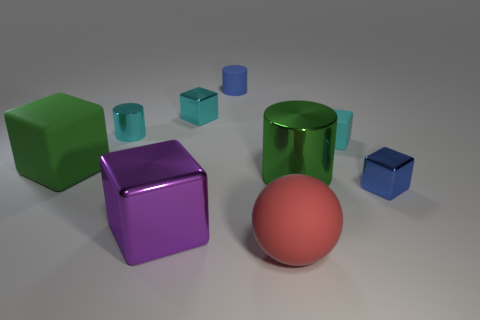Subtract all blue blocks. How many blocks are left? 4 Subtract all green rubber cubes. How many cubes are left? 4 Subtract all gray cubes. Subtract all yellow balls. How many cubes are left? 5 Add 1 blue blocks. How many objects exist? 10 Subtract all cylinders. How many objects are left? 6 Add 2 small brown matte cylinders. How many small brown matte cylinders exist? 2 Subtract 1 blue cylinders. How many objects are left? 8 Subtract all blue metallic objects. Subtract all green shiny cylinders. How many objects are left? 7 Add 8 small cyan cubes. How many small cyan cubes are left? 10 